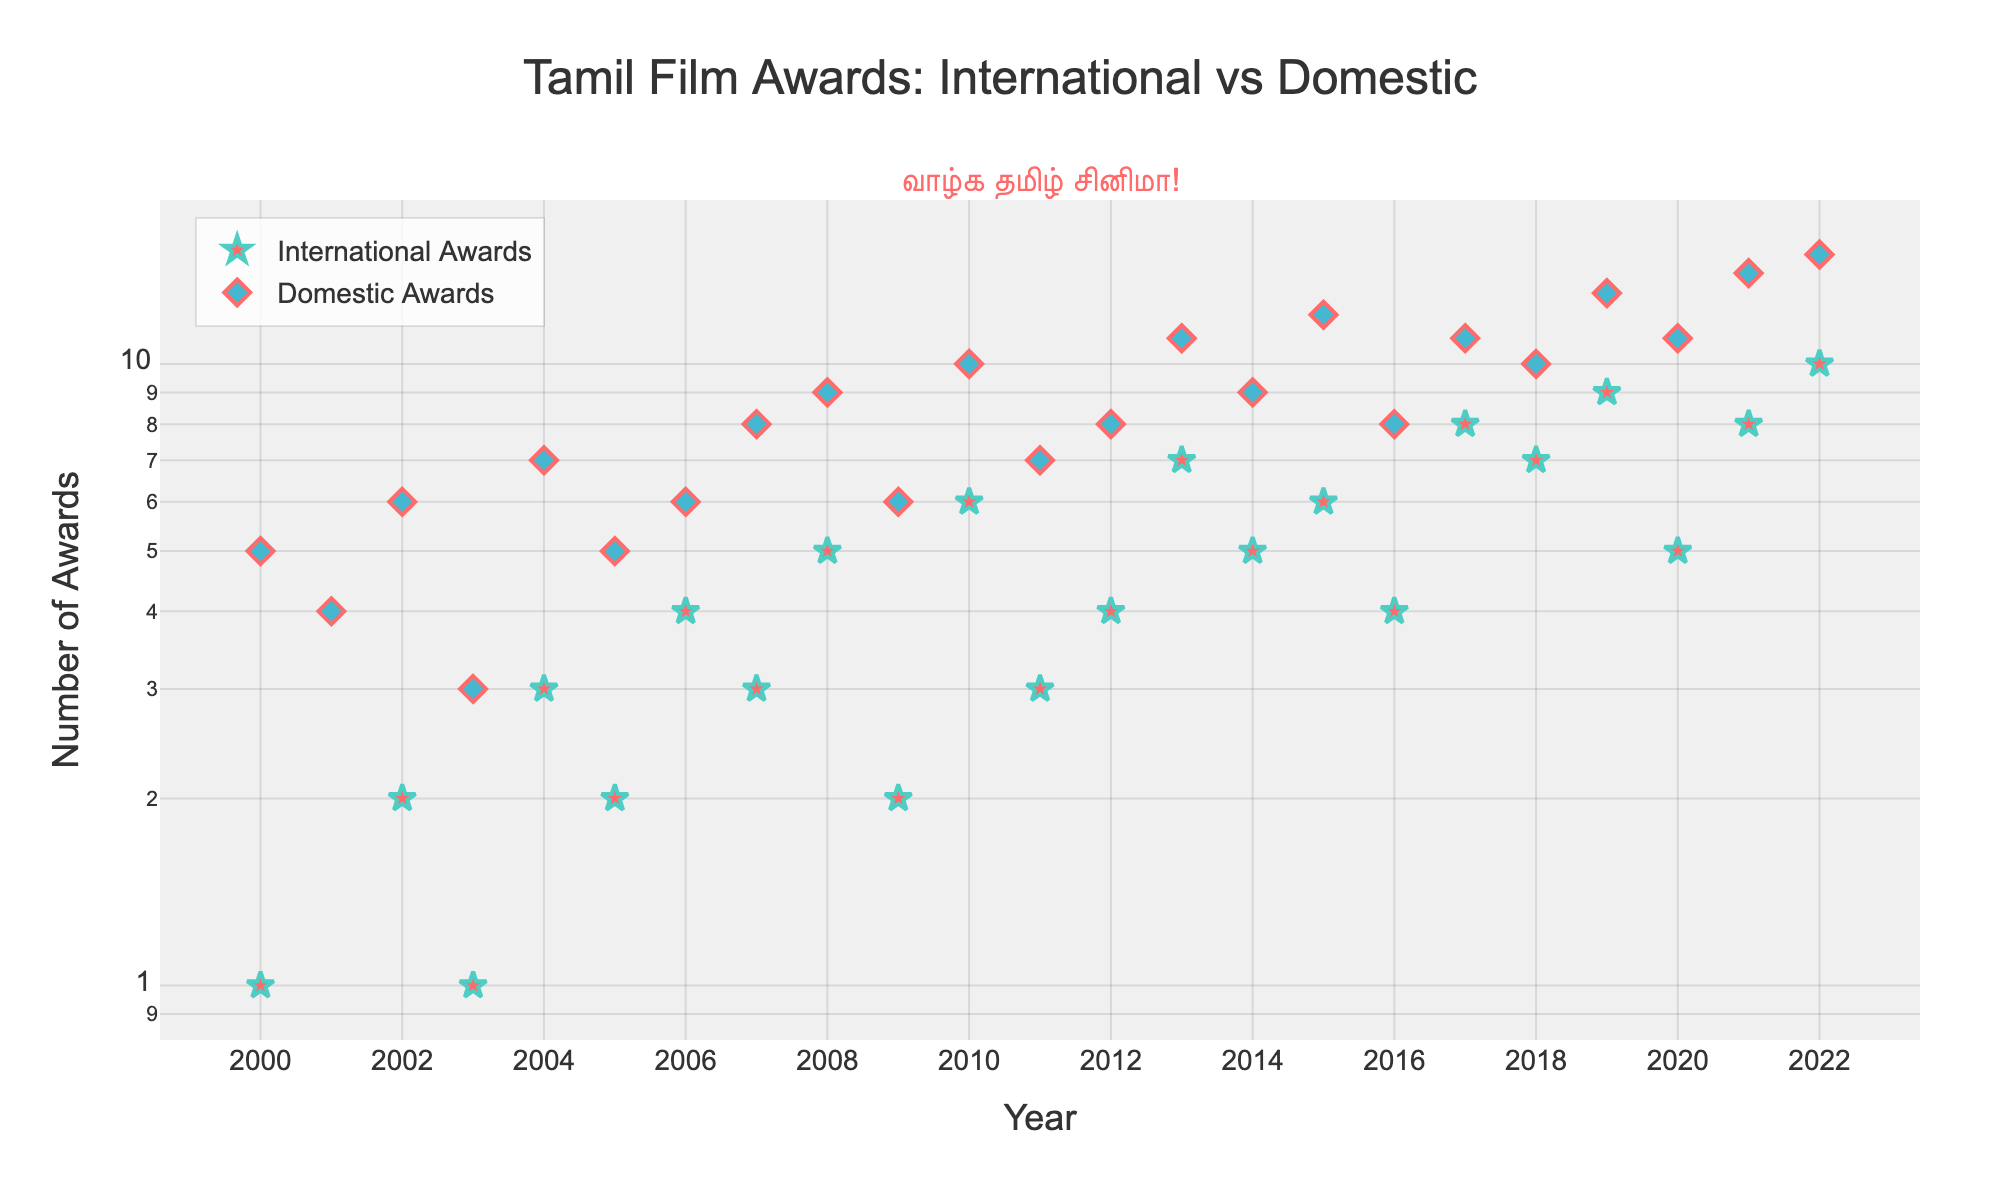What's the title of the scatter plot? The title of the scatter plot is often prominently displayed at the top of the figure. In this case, it shows a comparison of Tamil Film Awards.
Answer: Tamil Film Awards: International vs Domestic Which variable is represented on the x-axis? The x-axis represents the time variable, specifically the years from 2000 to 2022. This can be seen by looking at the axis title.
Answer: Year Which variable is represented on the y-axis? The y-axis represents the number of awards, both International and Domestic. This is indicated by the axis title "Number of Awards" and the log scale.
Answer: Number of Awards What are the colors used for International and Domestic Awards markers? By observing the plotted markers, International Awards are represented using a red color and Domestic Awards use a blue color.
Answer: Red for International, Blue for Domestic How many International Awards were won in the year 2013? Locate the point for the year 2013 on the x-axis and check its corresponding value on the y-axis under International Awards.
Answer: 7 In which year did Domestic Awards first reach double digits (10 or more)? Look for the first year on the x-axis where the Domestic Awards marker intersects the y-axis at 10 or above.
Answer: 2010 What's the difference in the number of International Awards between 2022 and 2000? Subtract the number of International Awards in 2000 from those in 2022. 10 (2022) - 1 (2000) = 9.
Answer: 9 Compare the trend in the number of awards over time for International and Domestic categories. Which category shows a steeper increase? Compare the slope of the scatter points for both categories from 2000 to 2022. Domestic Awards show a more consistent and steeper increase in comparison to International Awards.
Answer: Domestic Awards What's the highest number of Domestic Awards won in any given year within the dataset? Identify the highest position of the blue diamond markers on the y-axis.
Answer: 15 During which years did both International and Domestic Awards increase simultaneously compared to the previous year? Notice the years where both categories have an increase in award count when compared to the previous year. This occurs for years like 2008, 2010, 2013, 2015, 2019, and 2021.
Answer: 2008, 2010, 2013, 2015, 2019, 2021 